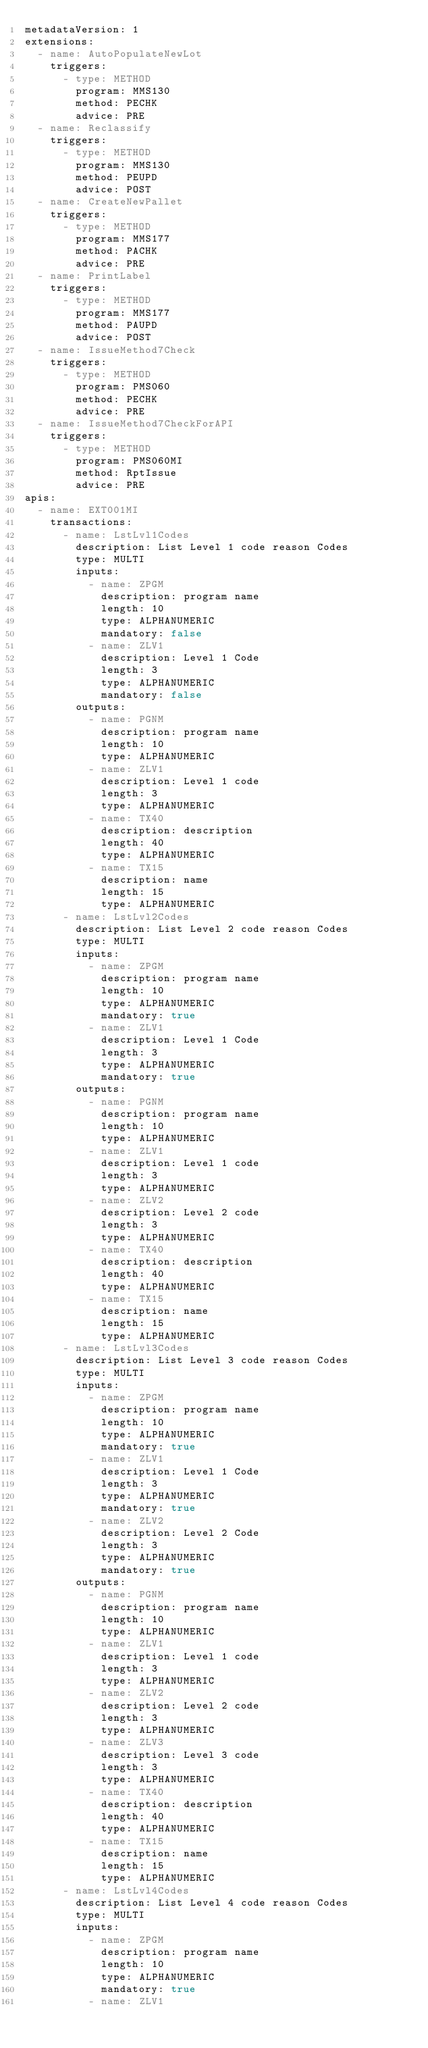Convert code to text. <code><loc_0><loc_0><loc_500><loc_500><_YAML_>metadataVersion: 1
extensions:
  - name: AutoPopulateNewLot
    triggers:
      - type: METHOD
        program: MMS130
        method: PECHK
        advice: PRE
  - name: Reclassify
    triggers:
      - type: METHOD
        program: MMS130
        method: PEUPD
        advice: POST
  - name: CreateNewPallet
    triggers:
      - type: METHOD
        program: MMS177
        method: PACHK
        advice: PRE
  - name: PrintLabel
    triggers:
      - type: METHOD
        program: MMS177
        method: PAUPD
        advice: POST
  - name: IssueMethod7Check
    triggers:
      - type: METHOD
        program: PMS060
        method: PECHK
        advice: PRE
  - name: IssueMethod7CheckForAPI
    triggers:
      - type: METHOD
        program: PMS060MI
        method: RptIssue
        advice: PRE
apis:
  - name: EXT001MI
    transactions:
      - name: LstLvl1Codes
        description: List Level 1 code reason Codes
        type: MULTI
        inputs:
          - name: ZPGM
            description: program name
            length: 10
            type: ALPHANUMERIC
            mandatory: false
          - name: ZLV1
            description: Level 1 Code
            length: 3
            type: ALPHANUMERIC
            mandatory: false
        outputs:
          - name: PGNM
            description: program name
            length: 10
            type: ALPHANUMERIC
          - name: ZLV1
            description: Level 1 code
            length: 3
            type: ALPHANUMERIC
          - name: TX40
            description: description
            length: 40
            type: ALPHANUMERIC
          - name: TX15
            description: name
            length: 15
            type: ALPHANUMERIC
      - name: LstLvl2Codes
        description: List Level 2 code reason Codes
        type: MULTI
        inputs:
          - name: ZPGM
            description: program name
            length: 10
            type: ALPHANUMERIC
            mandatory: true
          - name: ZLV1
            description: Level 1 Code
            length: 3
            type: ALPHANUMERIC
            mandatory: true
        outputs:
          - name: PGNM
            description: program name
            length: 10
            type: ALPHANUMERIC
          - name: ZLV1
            description: Level 1 code
            length: 3
            type: ALPHANUMERIC
          - name: ZLV2
            description: Level 2 code
            length: 3
            type: ALPHANUMERIC
          - name: TX40
            description: description
            length: 40
            type: ALPHANUMERIC
          - name: TX15
            description: name
            length: 15
            type: ALPHANUMERIC
      - name: LstLvl3Codes
        description: List Level 3 code reason Codes
        type: MULTI
        inputs:
          - name: ZPGM
            description: program name
            length: 10
            type: ALPHANUMERIC
            mandatory: true
          - name: ZLV1
            description: Level 1 Code
            length: 3
            type: ALPHANUMERIC
            mandatory: true
          - name: ZLV2
            description: Level 2 Code
            length: 3
            type: ALPHANUMERIC
            mandatory: true
        outputs:
          - name: PGNM
            description: program name
            length: 10
            type: ALPHANUMERIC
          - name: ZLV1
            description: Level 1 code
            length: 3
            type: ALPHANUMERIC
          - name: ZLV2
            description: Level 2 code
            length: 3
            type: ALPHANUMERIC
          - name: ZLV3
            description: Level 3 code
            length: 3
            type: ALPHANUMERIC
          - name: TX40
            description: description
            length: 40
            type: ALPHANUMERIC
          - name: TX15
            description: name
            length: 15
            type: ALPHANUMERIC
      - name: LstLvl4Codes
        description: List Level 4 code reason Codes
        type: MULTI
        inputs:
          - name: ZPGM
            description: program name
            length: 10
            type: ALPHANUMERIC
            mandatory: true
          - name: ZLV1</code> 